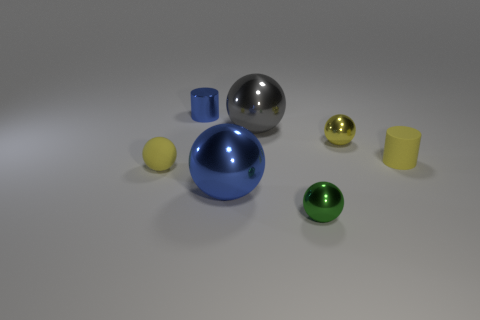Subtract all big blue balls. How many balls are left? 4 Subtract all yellow balls. How many balls are left? 3 Add 2 big blue matte cubes. How many objects exist? 9 Subtract 1 gray spheres. How many objects are left? 6 Subtract all cylinders. How many objects are left? 5 Subtract 4 balls. How many balls are left? 1 Subtract all cyan balls. Subtract all purple cylinders. How many balls are left? 5 Subtract all brown cylinders. How many gray balls are left? 1 Subtract all tiny green balls. Subtract all yellow objects. How many objects are left? 3 Add 6 yellow matte cylinders. How many yellow matte cylinders are left? 7 